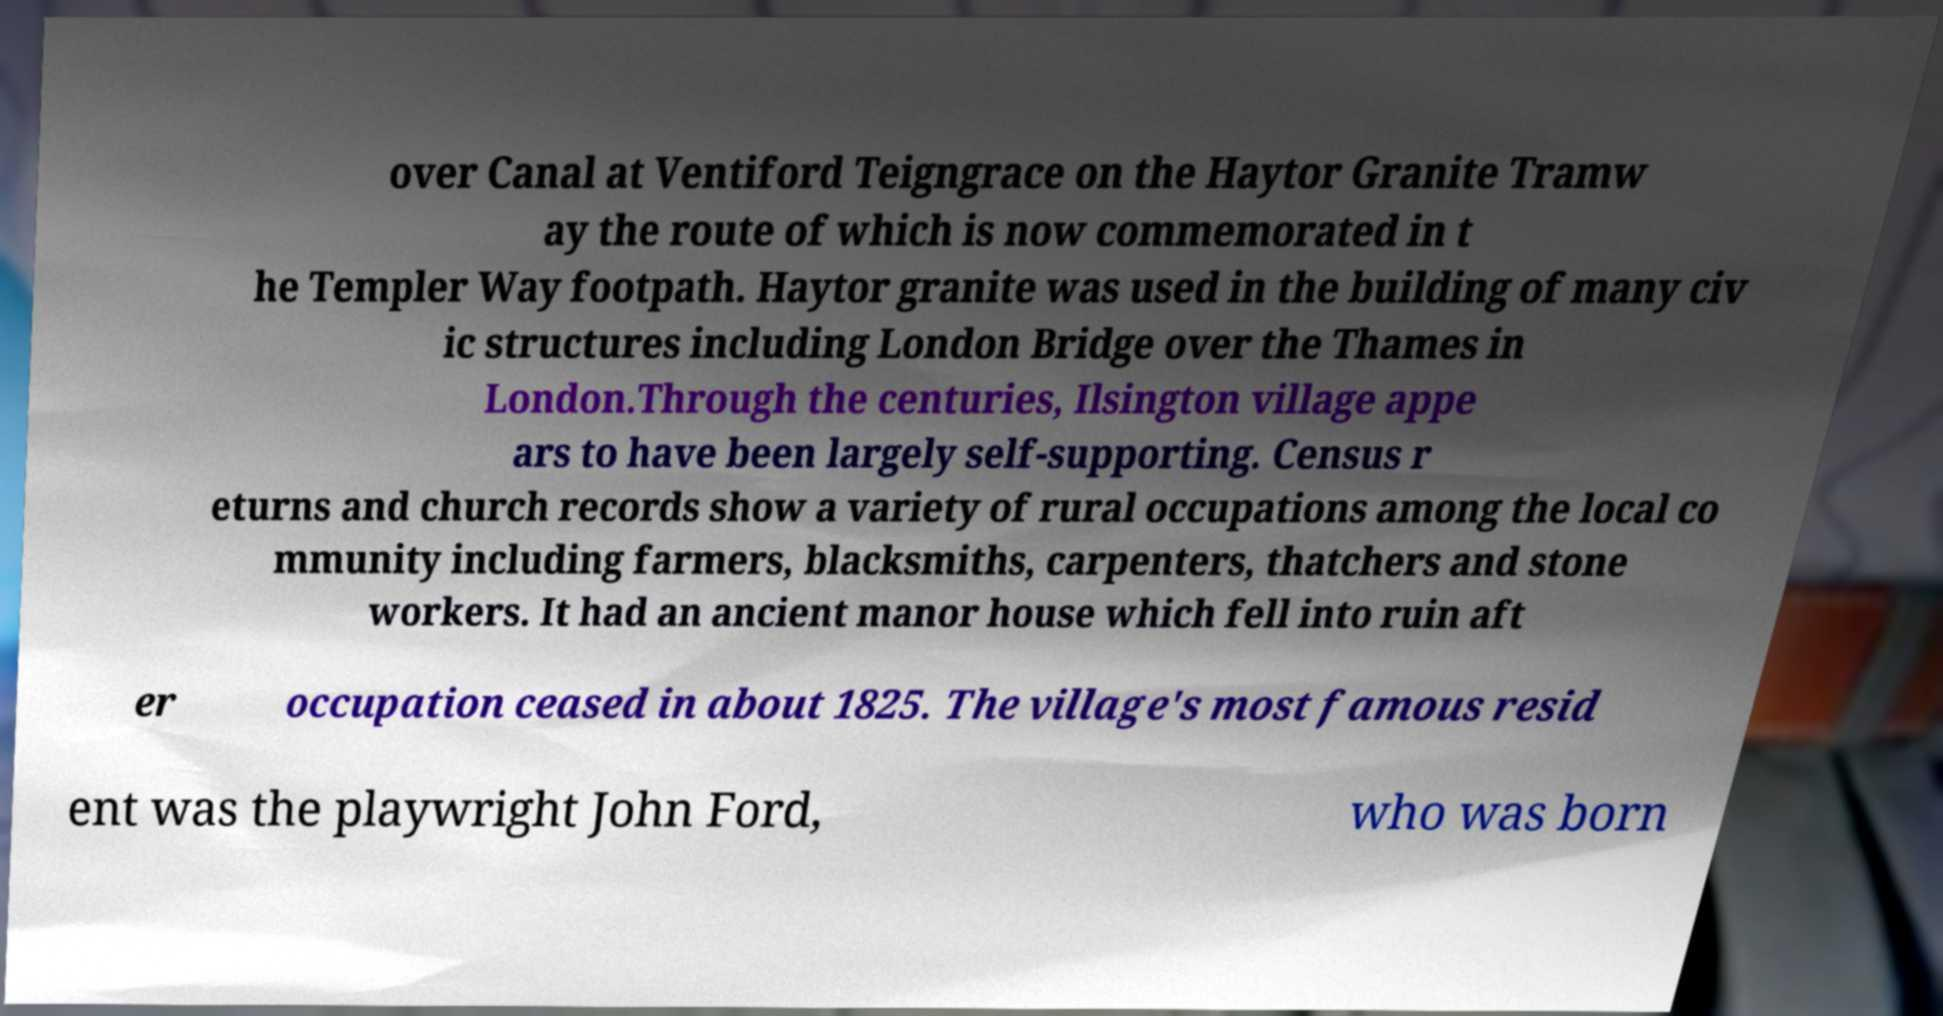I need the written content from this picture converted into text. Can you do that? over Canal at Ventiford Teigngrace on the Haytor Granite Tramw ay the route of which is now commemorated in t he Templer Way footpath. Haytor granite was used in the building of many civ ic structures including London Bridge over the Thames in London.Through the centuries, Ilsington village appe ars to have been largely self-supporting. Census r eturns and church records show a variety of rural occupations among the local co mmunity including farmers, blacksmiths, carpenters, thatchers and stone workers. It had an ancient manor house which fell into ruin aft er occupation ceased in about 1825. The village's most famous resid ent was the playwright John Ford, who was born 